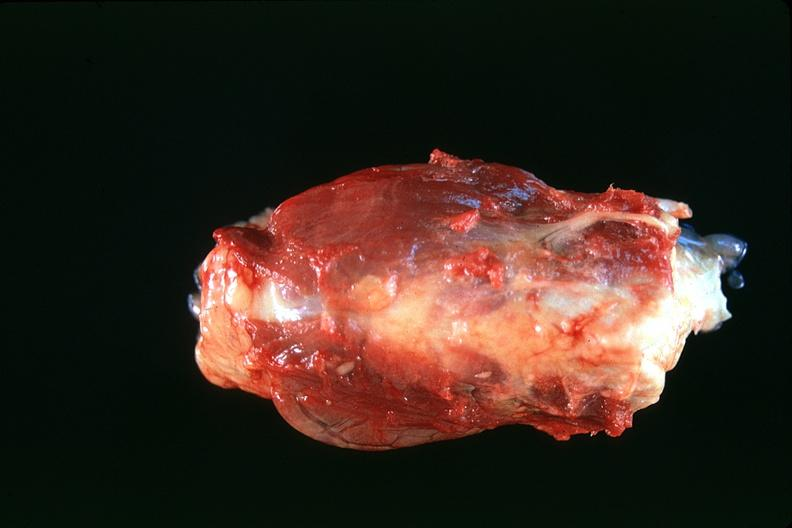what does this image show?
Answer the question using a single word or phrase. Thyroid 